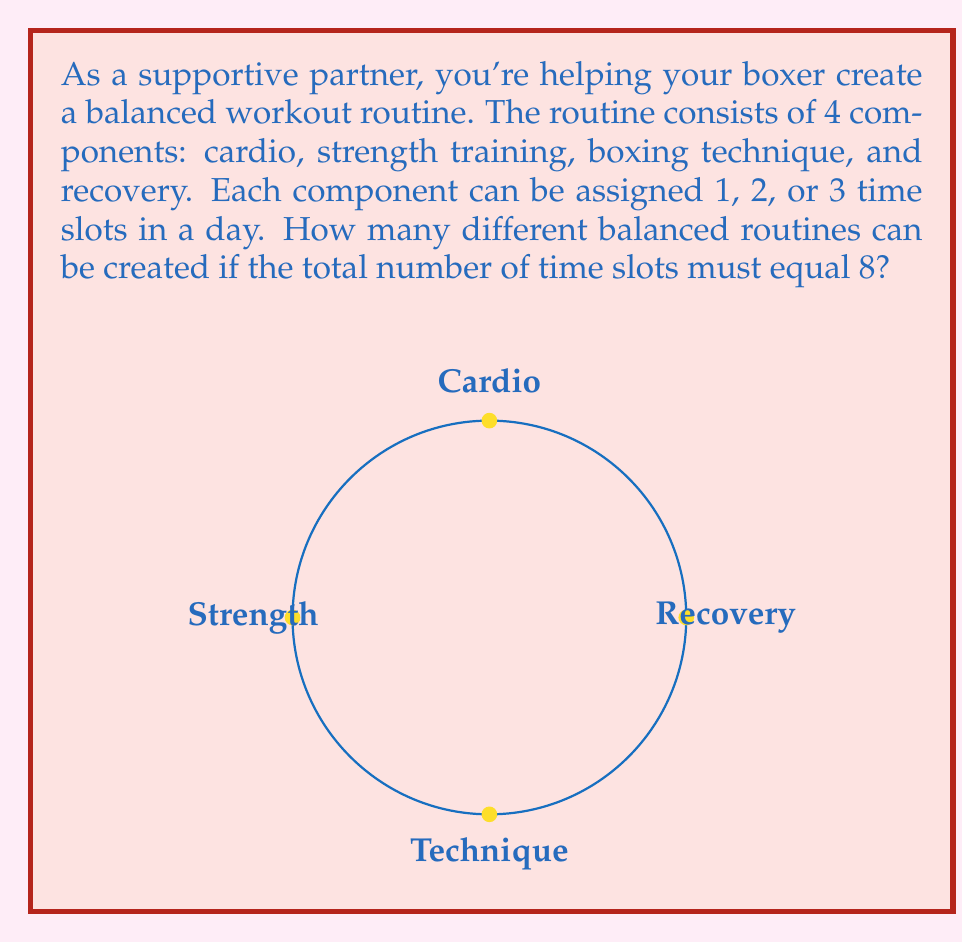Provide a solution to this math problem. Let's approach this step-by-step:

1) We need to find the number of ways to distribute 8 time slots among 4 components, where each component can have 1, 2, or 3 slots.

2) This is a classic stars and bars problem with restrictions. We can use the generating function method.

3) For each component, the possible number of slots can be represented as:
   $$(x + x^2 + x^3)$$

4) Since we have 4 components, our generating function will be:
   $$(x + x^2 + x^3)^4$$

5) We need to find the coefficient of $x^8$ in this expansion, as we want the total to be 8 slots.

6) Expanding $(x + x^2 + x^3)^4$ using a computer algebra system (as it's a complex expansion), we get:

   $$x^4 + 4x^5 + 10x^6 + 20x^7 + 35x^8 + 52x^9 + 68x^{10} + 76x^{11} + 69x^{12} + 48x^{13} + 24x^{14} + 8x^{15} + x^{16}$$

7) The coefficient of $x^8$ in this expansion is 35.

Therefore, there are 35 different ways to create a balanced workout routine under these conditions.
Answer: 35 